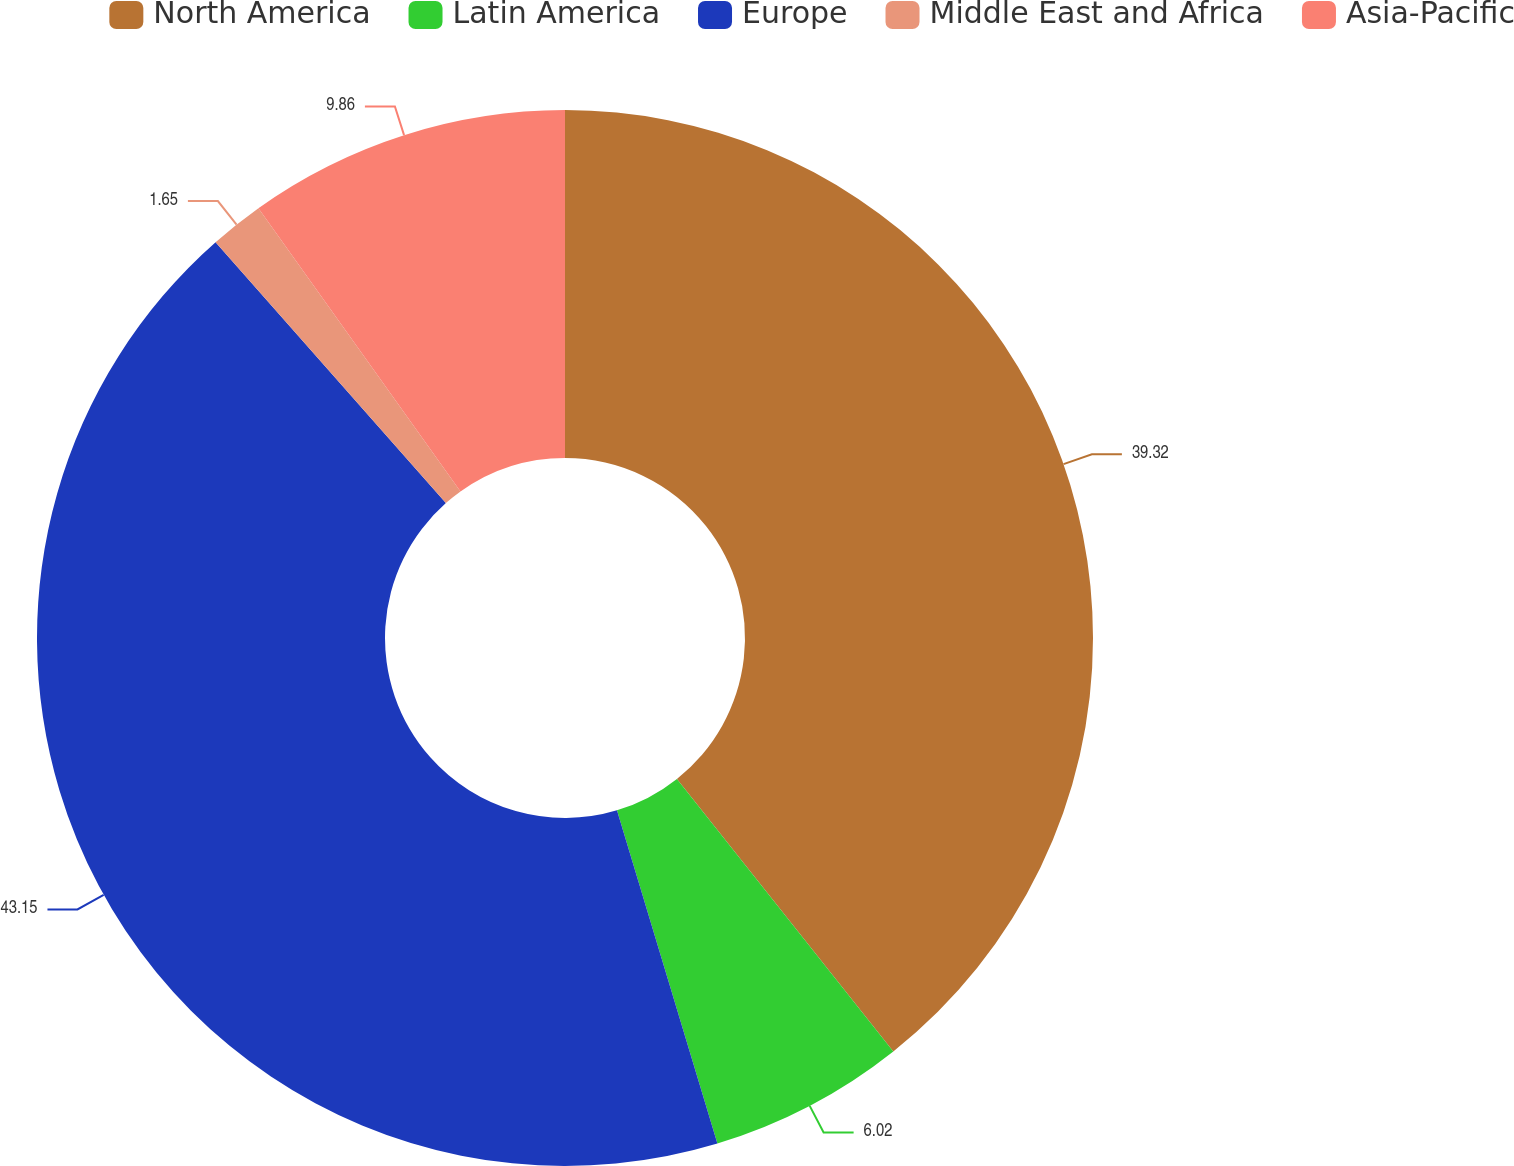Convert chart. <chart><loc_0><loc_0><loc_500><loc_500><pie_chart><fcel>North America<fcel>Latin America<fcel>Europe<fcel>Middle East and Africa<fcel>Asia-Pacific<nl><fcel>39.32%<fcel>6.02%<fcel>43.15%<fcel>1.65%<fcel>9.86%<nl></chart> 